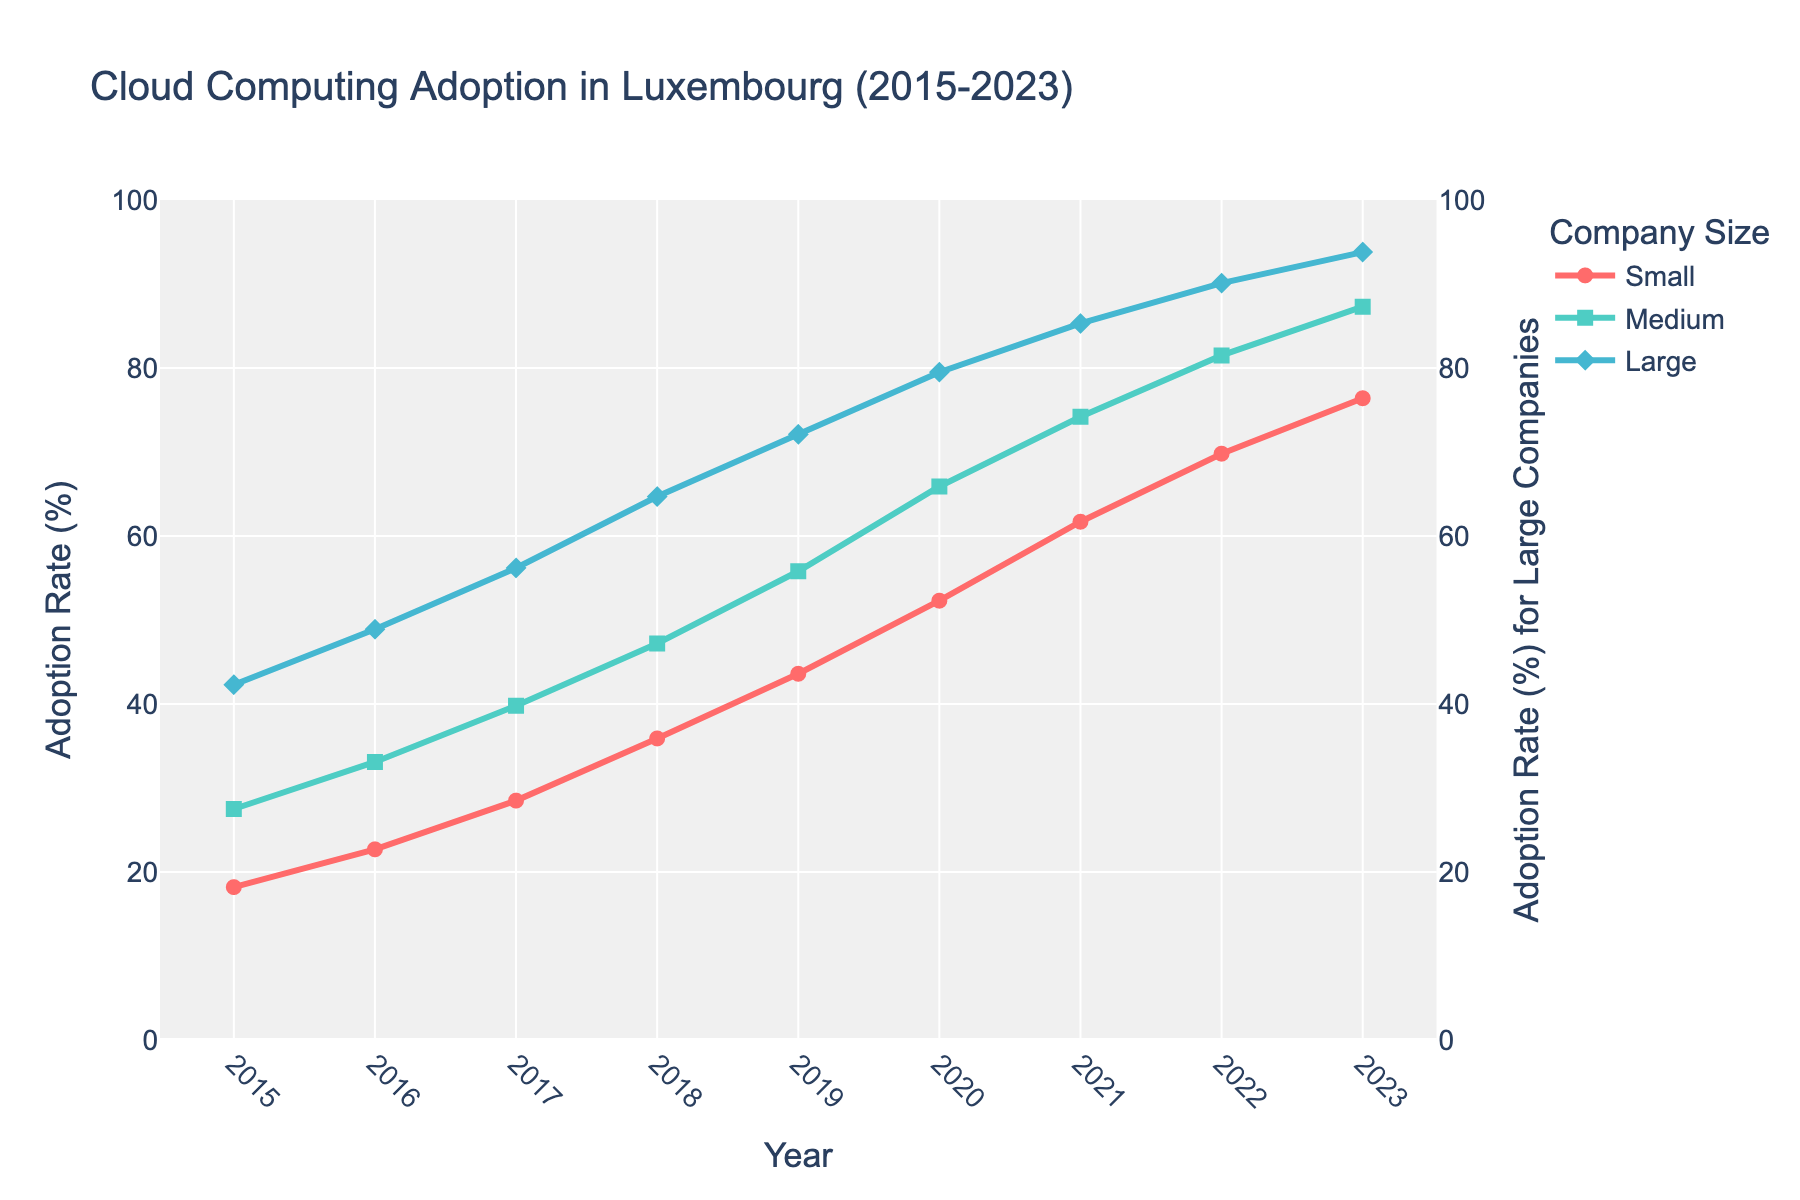What is the overall trend in cloud computing adoption among small businesses from 2015 to 2023? The line for small businesses shows a consistently increasing trend from 18.2% in 2015 to 76.4% in 2023.
Answer: Increasing Which company size group reached the highest adoption rate in 2023? The line for large companies shows the highest adoption rate of 93.8% in 2023.
Answer: Large companies In what year did medium-sized businesses surpass a 50% adoption rate? The line for medium-sized businesses crosses the 50% mark between 2018 and 2019, so the year is 2019.
Answer: 2019 By how much did the adoption rate among small businesses increase between 2015 and 2020? The adoption rate for small businesses increased from 18.2% in 2015 to 52.3% in 2020. Calculation: 52.3% - 18.2% = 34.1%
Answer: 34.1% Which year shows the largest year-over-year increase in adoption rate for large businesses? The largest single-year increase for large businesses is observed between 2015 and 2016, moving from 42.3% to 48.9%. Calculation: 48.9% - 42.3% = 6.6%
Answer: 2016 Compare the adoption rates of small and large businesses in 2021. Which had a higher rate and by how much? In 2021, small businesses had an adoption rate of 61.7%, whereas large businesses had 85.3%. Calculation: 85.3% - 61.7% = 23.6%. Large businesses had a higher rate by 23.6%.
Answer: Large by 23.6% What is the median adoption rate for medium-sized companies over the given period? The adoption rates for medium-sized companies are: 27.5, 33.1, 39.8, 47.2, 55.8, 65.9, 74.2, 81.5, 87.3. The median is the middle value when these rates are ordered. Median = 55.8%
Answer: 55.8% In 2017, what was the difference in adoption rate between medium and small businesses? In 2017, the adoption rate for medium-sized businesses was 39.8% and for small businesses was 28.5%. Calculation: 39.8% - 28.5% = 11.3%
Answer: 11.3% What is the average annual adoption rate increase for small businesses from 2015 to 2023? Calculate the total increase from 2015 to 2023 for small businesses: 76.4% - 18.2% = 58.2%. There are 8 intervals between 2015 and 2023. Average annual increase: 58.2% / 8 = 7.275%.
Answer: 7.275% How did the cloud computing adoption rates for all company sizes change between 2019 and 2020? Adoption rates for 2019: Small 43.6%, Medium 55.8%, Large 72.1%. For 2020: Small 52.3%, Medium 65.9%, Large 79.5%. Changes: Small 52.3% - 43.6% = 8.7%, Medium 65.9% - 55.8% = 10.1%, Large 79.5% - 72.1% = 7.4%.
Answer: Small 8.7%, Medium 10.1%, Large 7.4% 